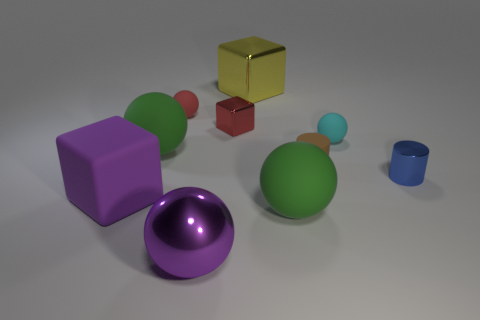Subtract all large green rubber spheres. How many spheres are left? 3 Subtract 3 balls. How many balls are left? 2 Subtract all purple balls. How many balls are left? 4 Subtract all blue spheres. Subtract all purple blocks. How many spheres are left? 5 Subtract all blue metal cylinders. Subtract all metallic objects. How many objects are left? 5 Add 4 red spheres. How many red spheres are left? 5 Add 4 rubber cubes. How many rubber cubes exist? 5 Subtract 1 yellow cubes. How many objects are left? 9 Subtract all cylinders. How many objects are left? 8 